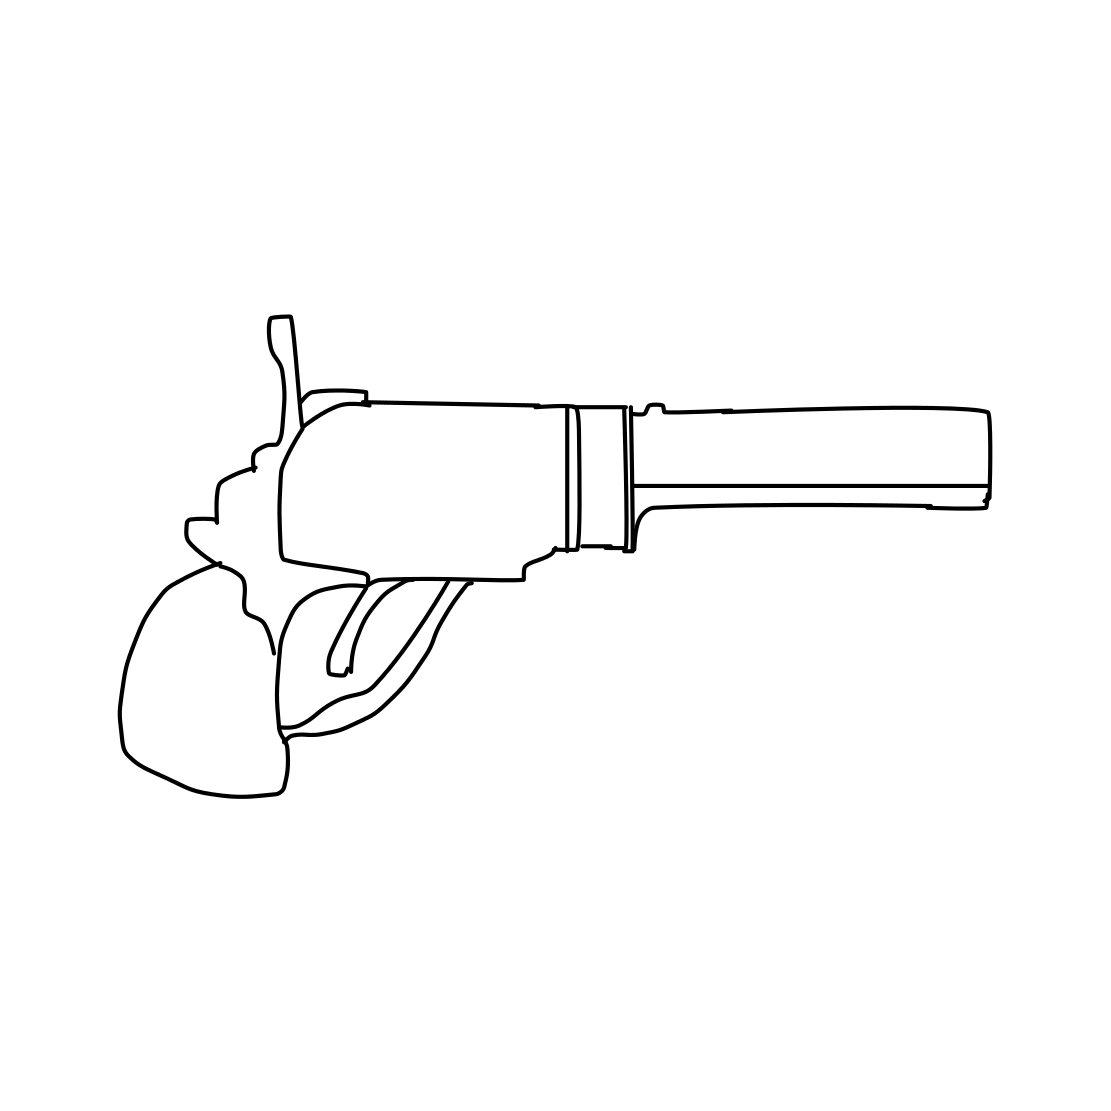Is there a sketchy revolver in the picture? Yes 